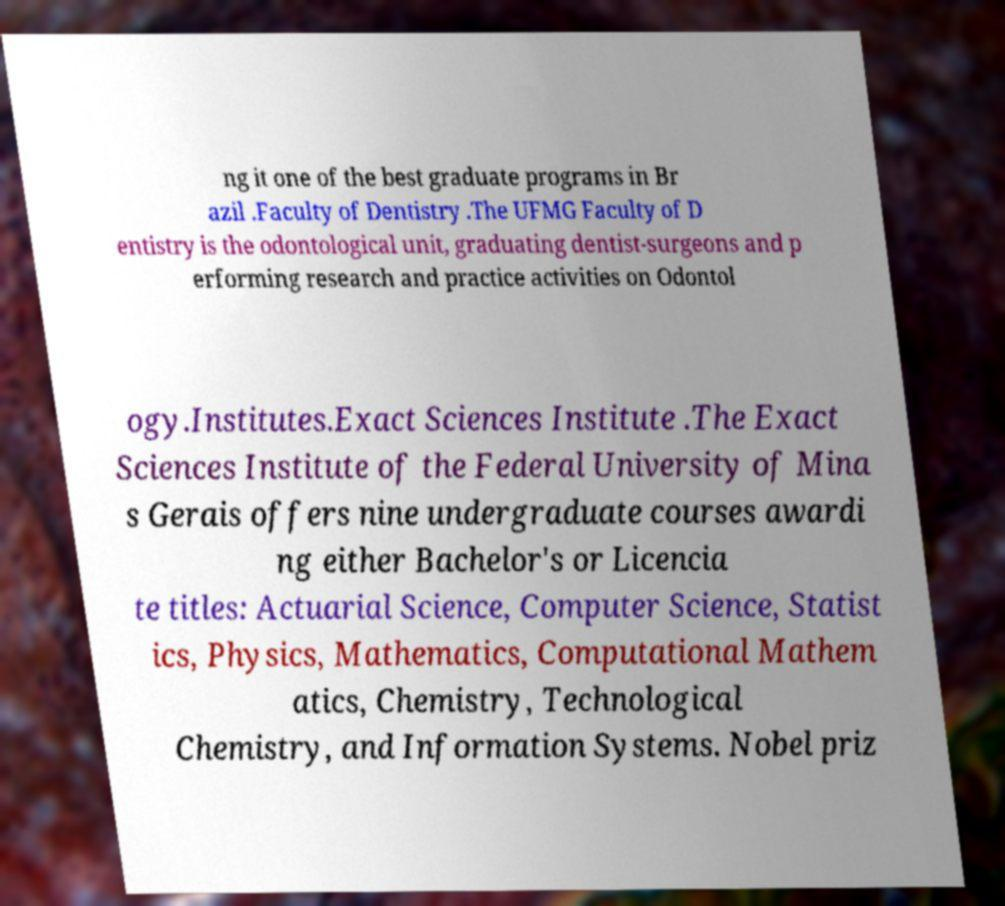I need the written content from this picture converted into text. Can you do that? ng it one of the best graduate programs in Br azil .Faculty of Dentistry .The UFMG Faculty of D entistry is the odontological unit, graduating dentist-surgeons and p erforming research and practice activities on Odontol ogy.Institutes.Exact Sciences Institute .The Exact Sciences Institute of the Federal University of Mina s Gerais offers nine undergraduate courses awardi ng either Bachelor's or Licencia te titles: Actuarial Science, Computer Science, Statist ics, Physics, Mathematics, Computational Mathem atics, Chemistry, Technological Chemistry, and Information Systems. Nobel priz 